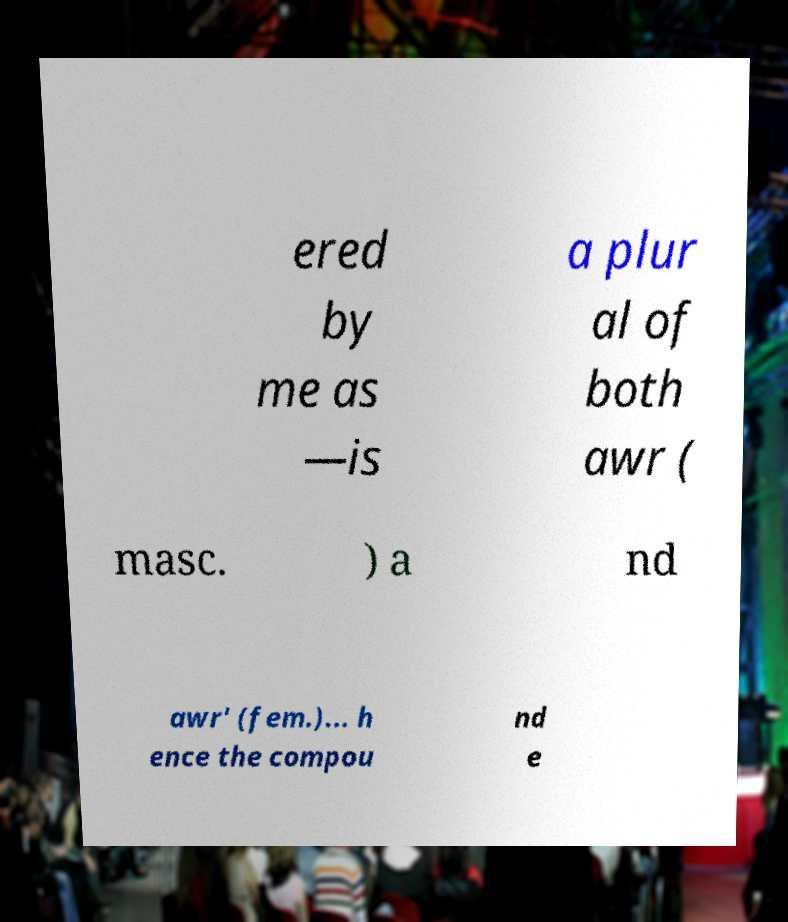I need the written content from this picture converted into text. Can you do that? ered by me as —is a plur al of both awr ( masc. ) a nd awr' (fem.)... h ence the compou nd e 